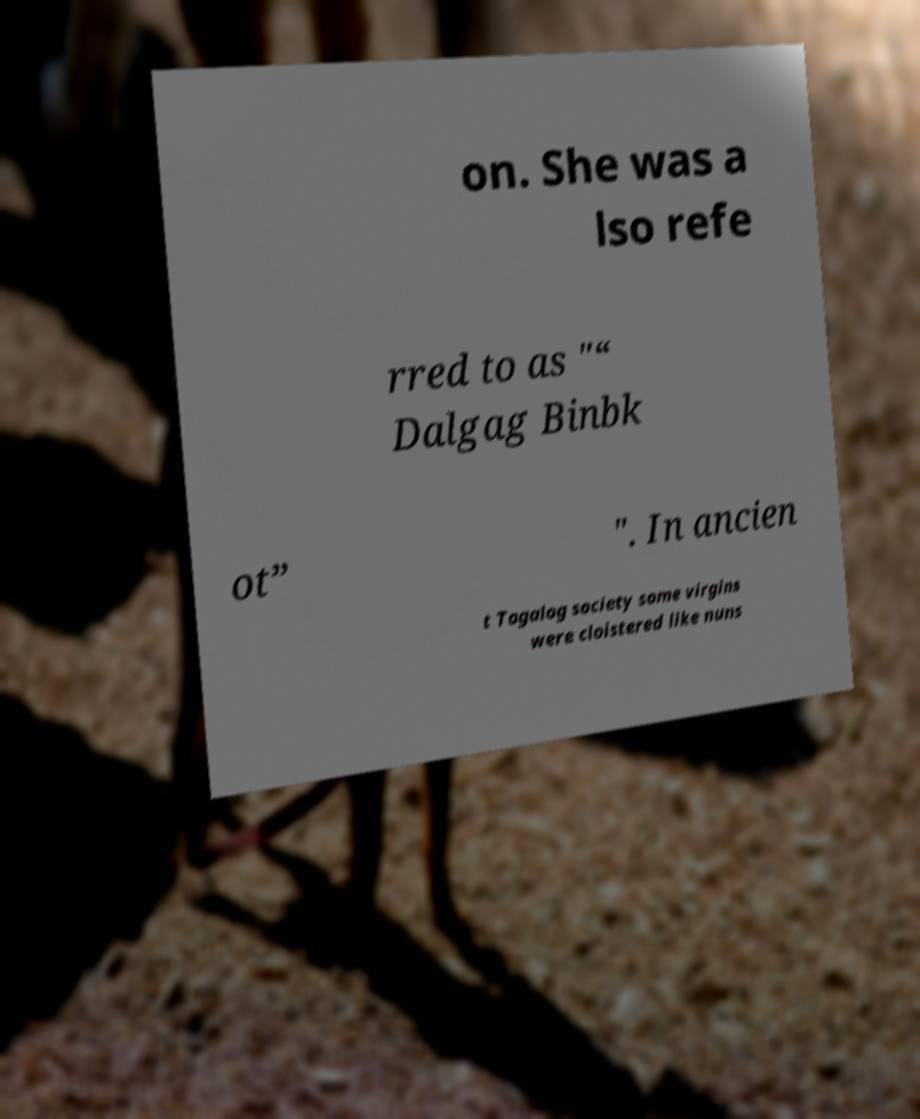Could you assist in decoding the text presented in this image and type it out clearly? on. She was a lso refe rred to as "“ Dalgag Binbk ot” ". In ancien t Tagalog society some virgins were cloistered like nuns 